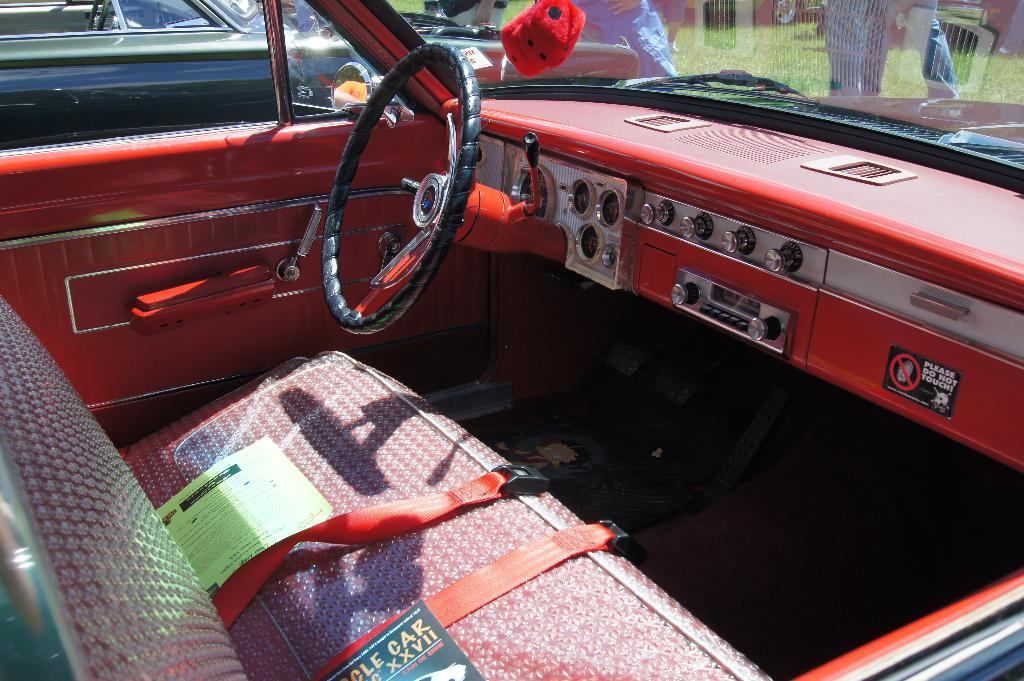What is the main object in the foreground of the image? There is a steering wheel in the foreground of the image. What other objects are in the foreground of the image? There are switches, a seat with bubble wrap, and papers in the foreground of the image. Can you describe the scene outside the car in the image? There is another car visible outside the car, and there are persons outside the car in the image. How many women are visible in the image? There is no mention of women in the provided facts, so it cannot be determined from the image. What type of zinc is used in the construction of the car in the image? There is no information about the materials used in the construction of the car in the provided facts, so it cannot be determined from the image. 